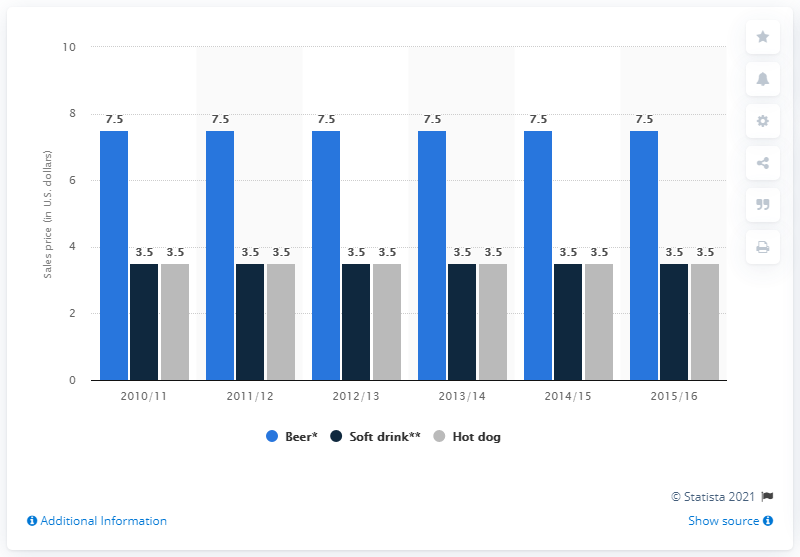Draw attention to some important aspects in this diagram. The maximum price of beer over the years has been lower than the minimum price of hot dogs. In 2010-11, the price of beer was significantly higher than the price of hot dogs, indicating that consumers were willing to pay more for beer than for hot dogs during that time period. 